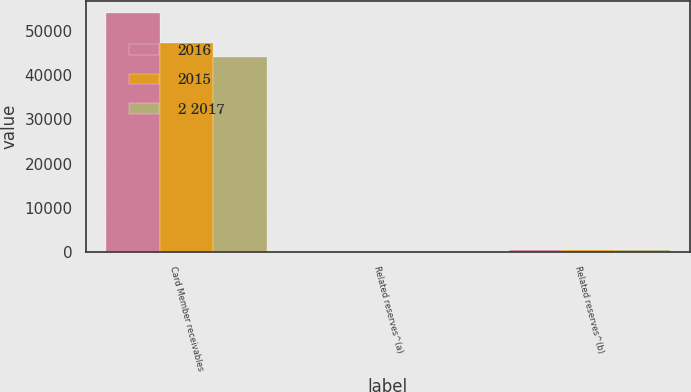Convert chart to OTSL. <chart><loc_0><loc_0><loc_500><loc_500><stacked_bar_chart><ecel><fcel>Card Member receivables<fcel>Related reserves^(a)<fcel>Related reserves^(b)<nl><fcel>2016<fcel>53967<fcel>3<fcel>518<nl><fcel>2015<fcel>47253<fcel>28<fcel>439<nl><fcel>2 2017<fcel>44100<fcel>20<fcel>442<nl></chart> 